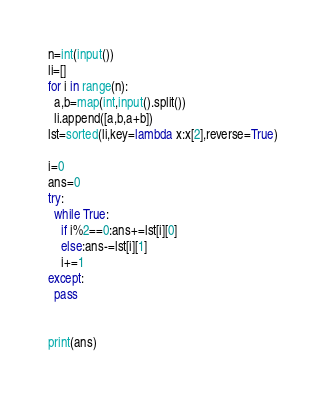<code> <loc_0><loc_0><loc_500><loc_500><_Python_>n=int(input())
li=[]
for i in range(n):
  a,b=map(int,input().split())
  li.append([a,b,a+b])
lst=sorted(li,key=lambda x:x[2],reverse=True)

i=0
ans=0
try:
  while True:
    if i%2==0:ans+=lst[i][0]
    else:ans-=lst[i][1]
    i+=1
except:
  pass
    
    
print(ans)</code> 